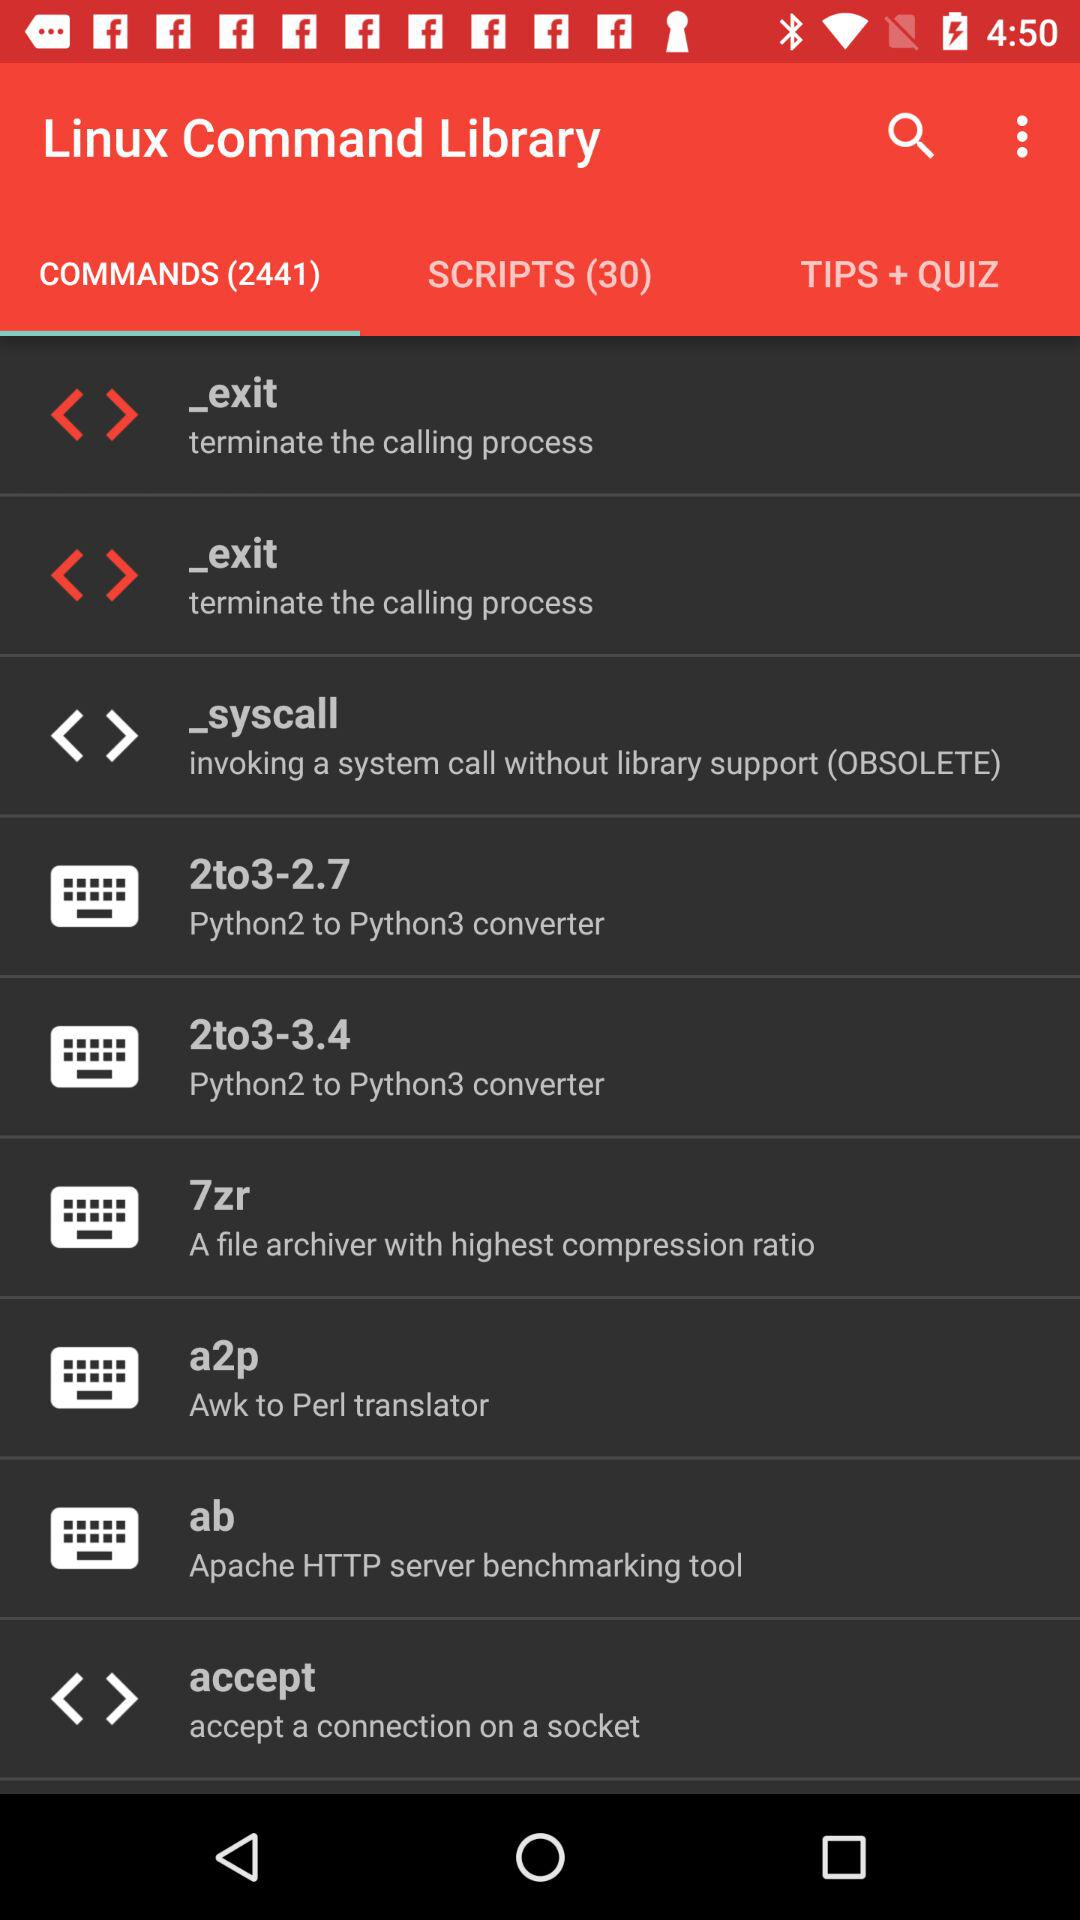Which items are listed in "SCRIPTS"?
When the provided information is insufficient, respond with <no answer>. <no answer> 